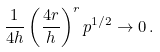<formula> <loc_0><loc_0><loc_500><loc_500>\frac { 1 } { 4 h } \left ( \frac { 4 r } { h } \right ) ^ { r } p ^ { 1 / 2 } \to 0 \, .</formula> 